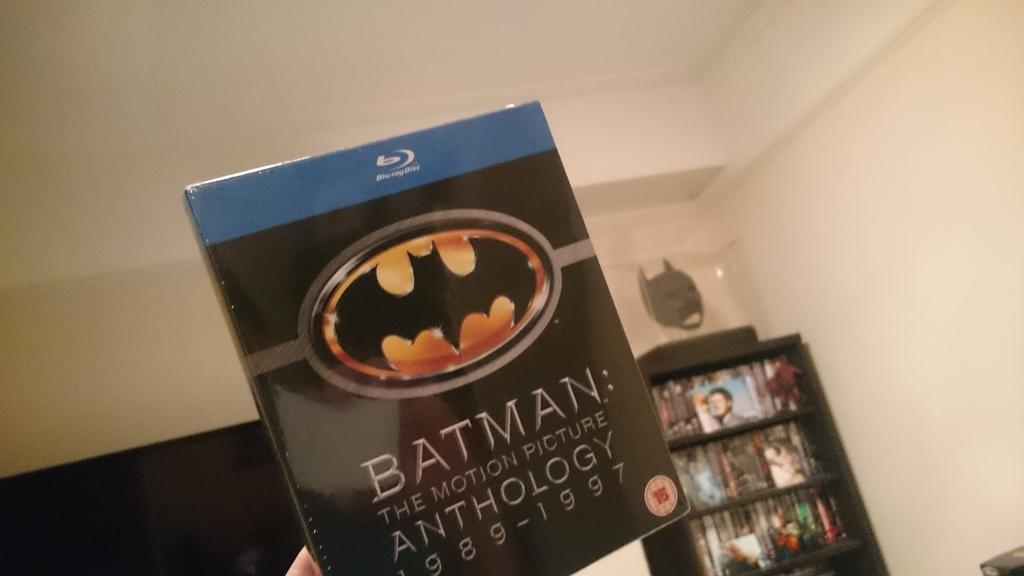<image>
Offer a succinct explanation of the picture presented. A hand is holding up a blu-ray copy of Batman:The Motion Picture Anthology 1989 -1997 